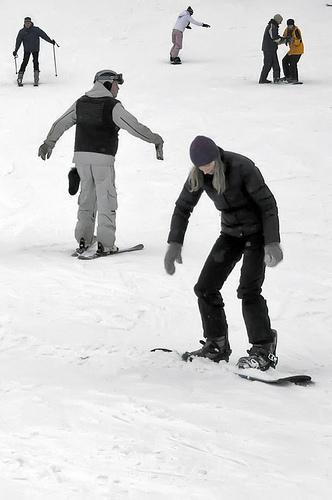What skill level do most snowboarders here have? beginner 